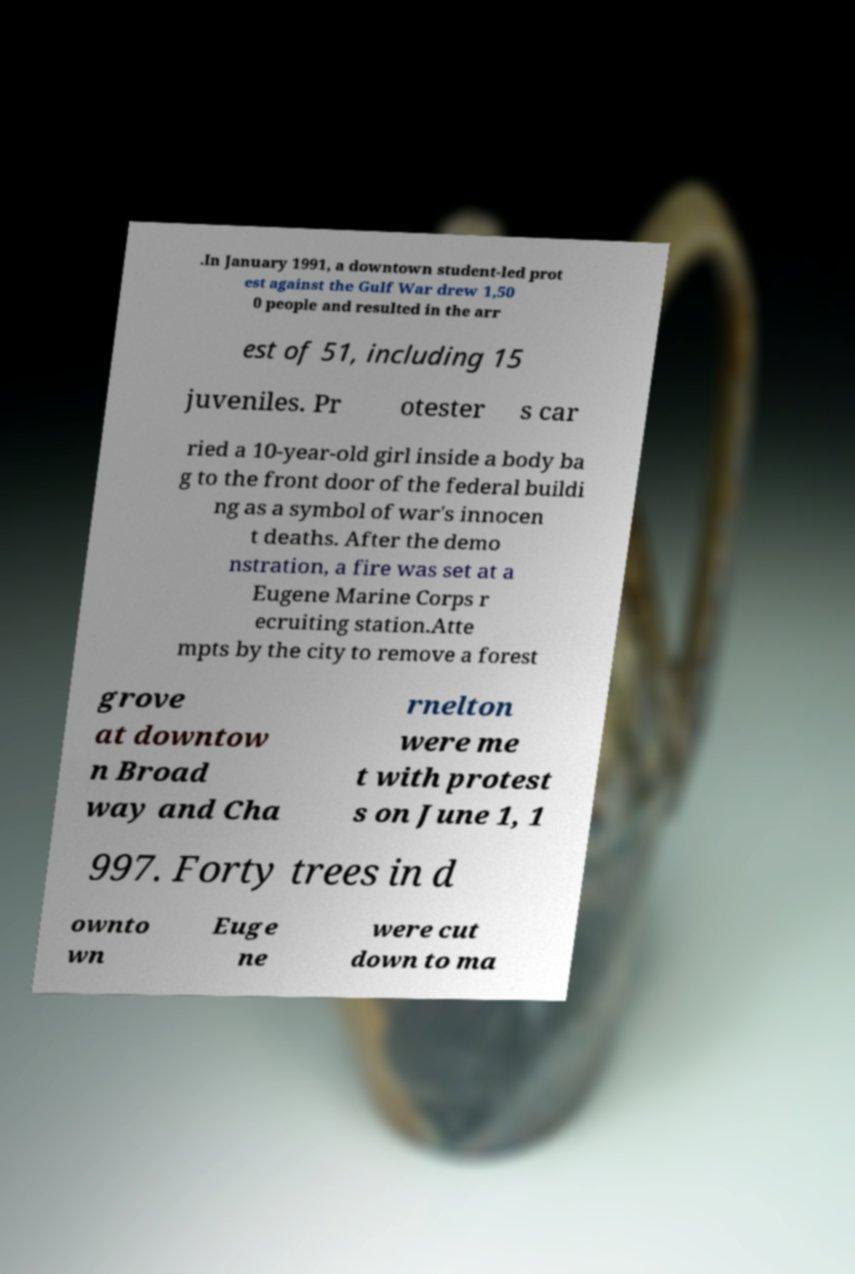Could you extract and type out the text from this image? .In January 1991, a downtown student-led prot est against the Gulf War drew 1,50 0 people and resulted in the arr est of 51, including 15 juveniles. Pr otester s car ried a 10-year-old girl inside a body ba g to the front door of the federal buildi ng as a symbol of war's innocen t deaths. After the demo nstration, a fire was set at a Eugene Marine Corps r ecruiting station.Atte mpts by the city to remove a forest grove at downtow n Broad way and Cha rnelton were me t with protest s on June 1, 1 997. Forty trees in d ownto wn Euge ne were cut down to ma 